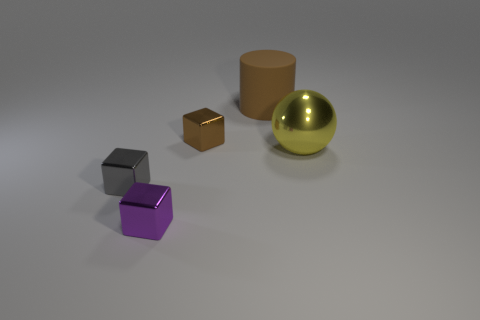What number of other objects are there of the same color as the rubber cylinder?
Your answer should be compact. 1. Is there anything else that has the same material as the large brown object?
Make the answer very short. No. Are there any rubber things that are in front of the large shiny ball in front of the tiny block behind the big ball?
Offer a terse response. No. Is there anything else that has the same shape as the yellow metallic thing?
Make the answer very short. No. Is there a yellow shiny sphere?
Give a very brief answer. Yes. Does the small object behind the big yellow sphere have the same material as the big object behind the small brown block?
Make the answer very short. No. What size is the metallic object that is right of the brown object that is to the right of the block that is behind the yellow sphere?
Provide a short and direct response. Large. What number of yellow balls have the same material as the small brown object?
Offer a terse response. 1. Is the number of small purple metal spheres less than the number of brown things?
Give a very brief answer. Yes. There is a brown thing that is the same shape as the purple metallic object; what is its size?
Make the answer very short. Small. 